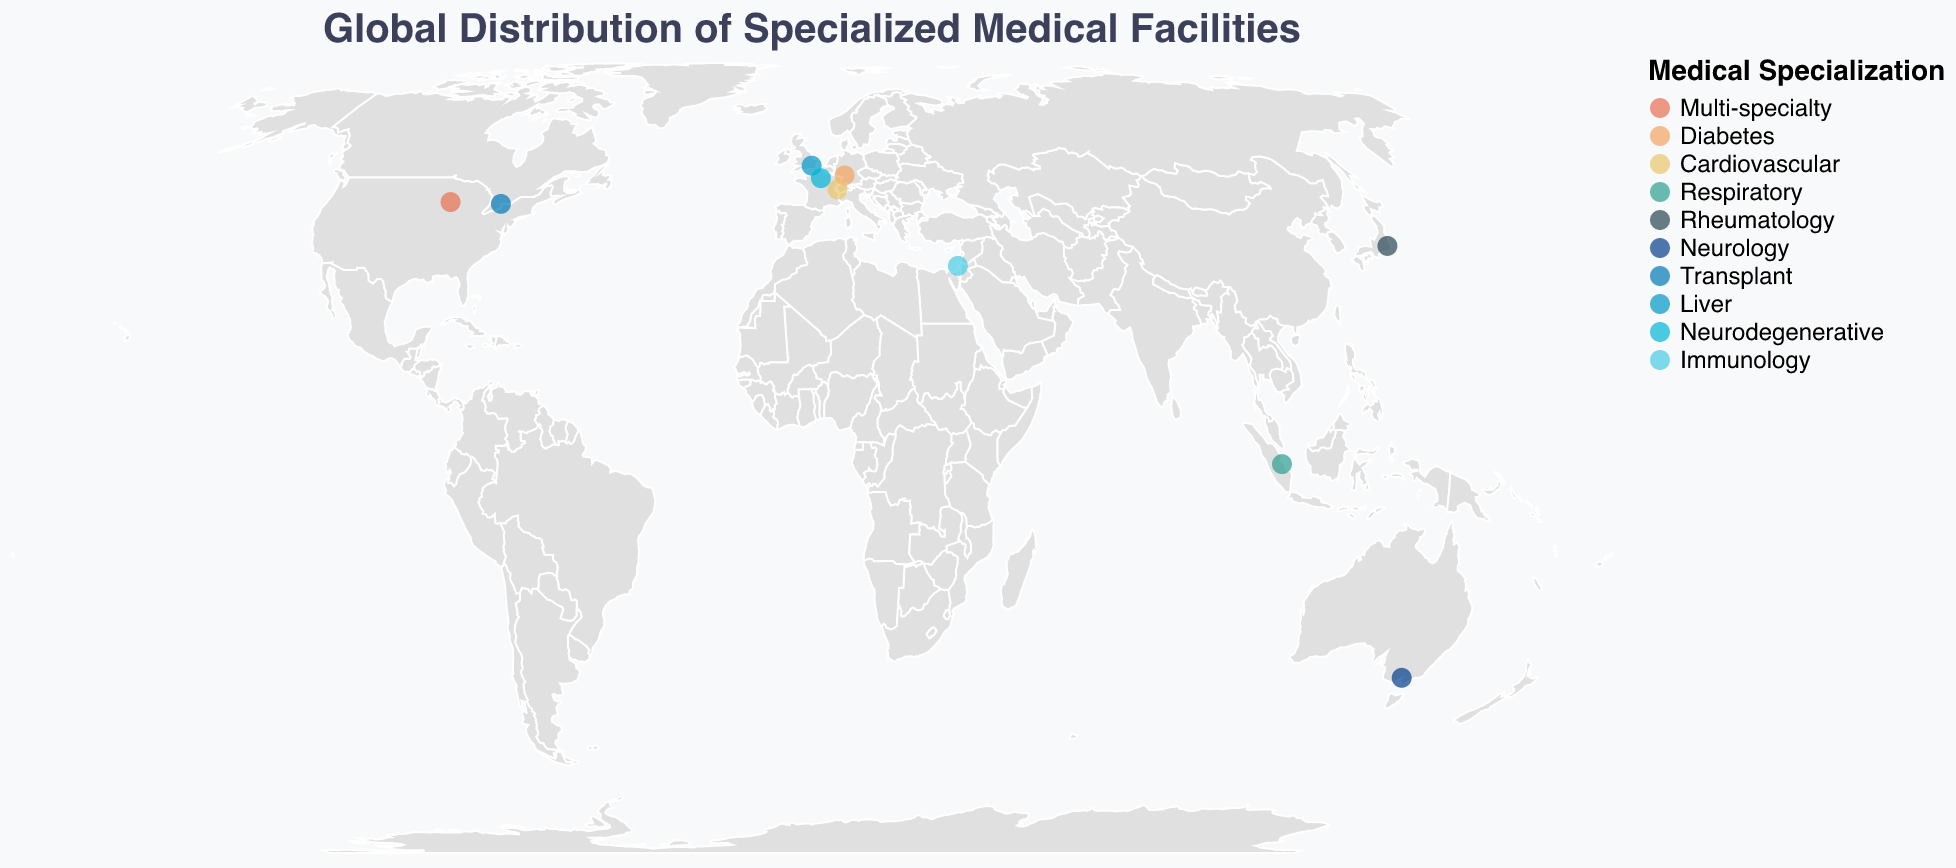What is the title of the figure? The title of the figure is displayed at the top and provides a summary of the visualization content. The title here is "Global Distribution of Specialized Medical Facilities."
Answer: Global Distribution of Specialized Medical Facilities What are the specializations covered by medical facilities in the figure? The legend in the figure displays the different specializations covered by the medical facilities. These are: Multi-specialty, Diabetes, Cardiovascular, Respiratory, Rheumatology, Neurology, Transplant, Liver, Neurodegenerative, and Immunology.
Answer: Multi-specialty, Diabetes, Cardiovascular, Respiratory, Rheumatology, Neurology, Transplant, Liver, Neurodegenerative, Immunology Which facility in Asia is specialized in Rheumatology? By looking at the tooltip and geographical location, we can identify the facility in Asia (Japan) specialized in Rheumatology. The facility name is "Tokyo Medical and Dental University Hospital" located in Tokyo, Japan.
Answer: Tokyo Medical and Dental University Hospital How many specialized medical facilities are displayed on the map? By counting the number of specific points marked on the global map, we can determine the total number of specialized medical facilities. There are 10 such facilities on the map.
Answer: 10 Which country has a facility specialized in Neurodegenerative conditions? To find this, locate the medical facility with the specialization 'Neurodegenerative' from the tooltip information. The relevant country is France, with the facility named "Pitié-Salpêtrière Hospital".
Answer: France Which facility is located furthest south on the map? By observing the latitude values on the map, the facility with the smallest latitude value (located furthest south) is in Melbourne, Australia. This facility is "Royal Melbourne Hospital."
Answer: Royal Melbourne Hospital Compare the specializations in Europe. Which specializations are found there? The facilities located in Europe are in Germany (Heidelberg), Switzerland (Lausanne), the UK (London), and France (Paris). The specializations are Diabetes (Germany), Cardiovascular (Switzerland), Liver (UK), and Neurodegenerative (France).
Answer: Diabetes, Cardiovascular, Liver, Neurodegenerative Which continent has the highest number of specialized medical facilities represented on the figure? By identifying and counting the medical facilities by continent: North America (2), Europe (4), Asia (2), Australia (1), and the Middle East (1), Europe has the highest number of facilities.
Answer: Europe 